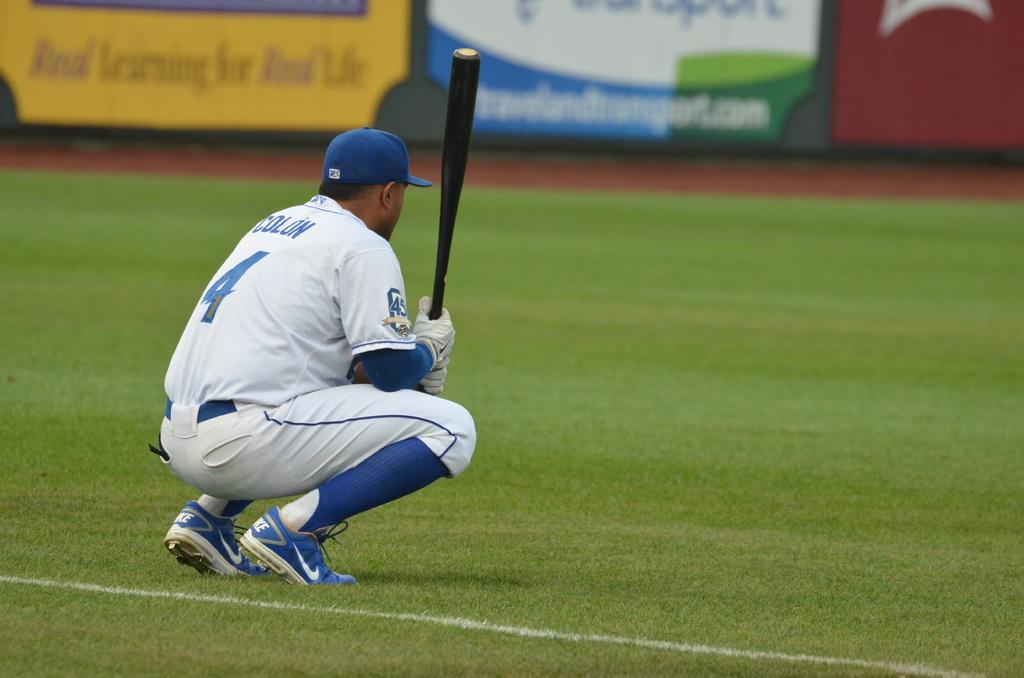<image>
Summarize the visual content of the image. Player number 4 is crouched down holding a black bat. 